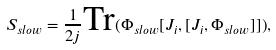Convert formula to latex. <formula><loc_0><loc_0><loc_500><loc_500>S _ { s l o w } = \frac { 1 } { 2 j } \text {Tr} ( \Phi _ { s l o w } [ J _ { i } , [ J _ { i } , \Phi _ { s l o w } ] ] ) ,</formula> 